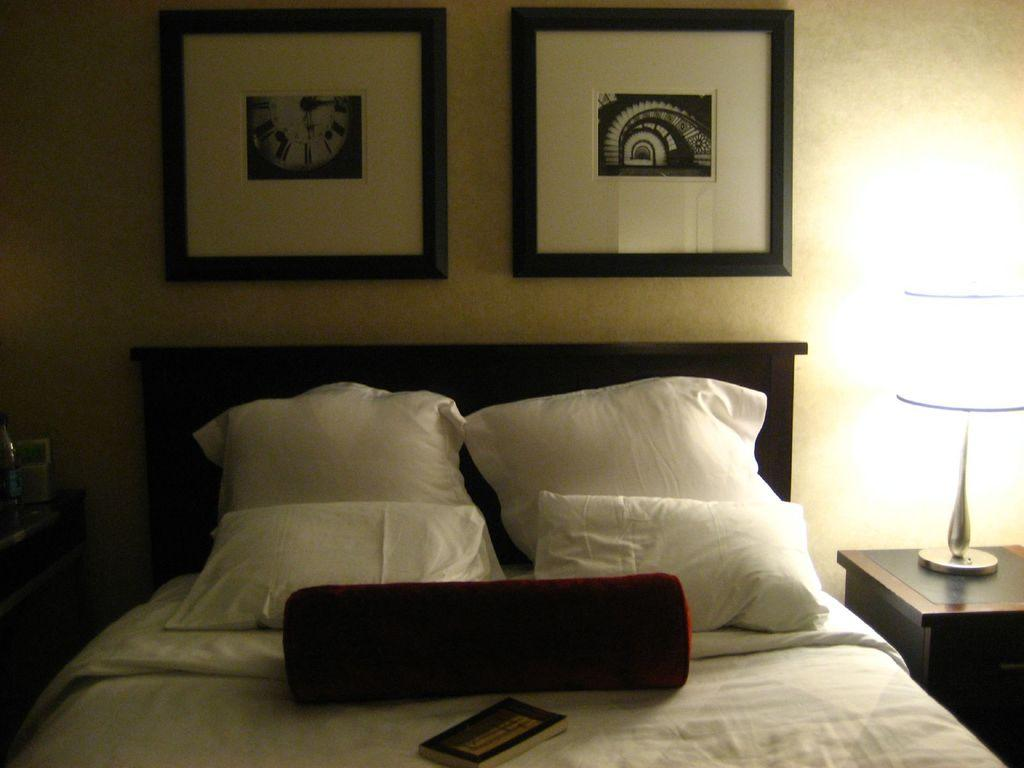What object is placed on the bed in the image? There is a book on the bed. What type of decoration can be seen on the walls in the image? There are wall paintings in the image. Can you describe the source of light in the image? There is a light in the image. What type of test can be seen being conducted in the image? There is no test being conducted in the image; it features a book on the bed, wall paintings, and a light. How does the mist affect the visibility in the image? There is no mist present in the image, so its effect on visibility cannot be determined. 